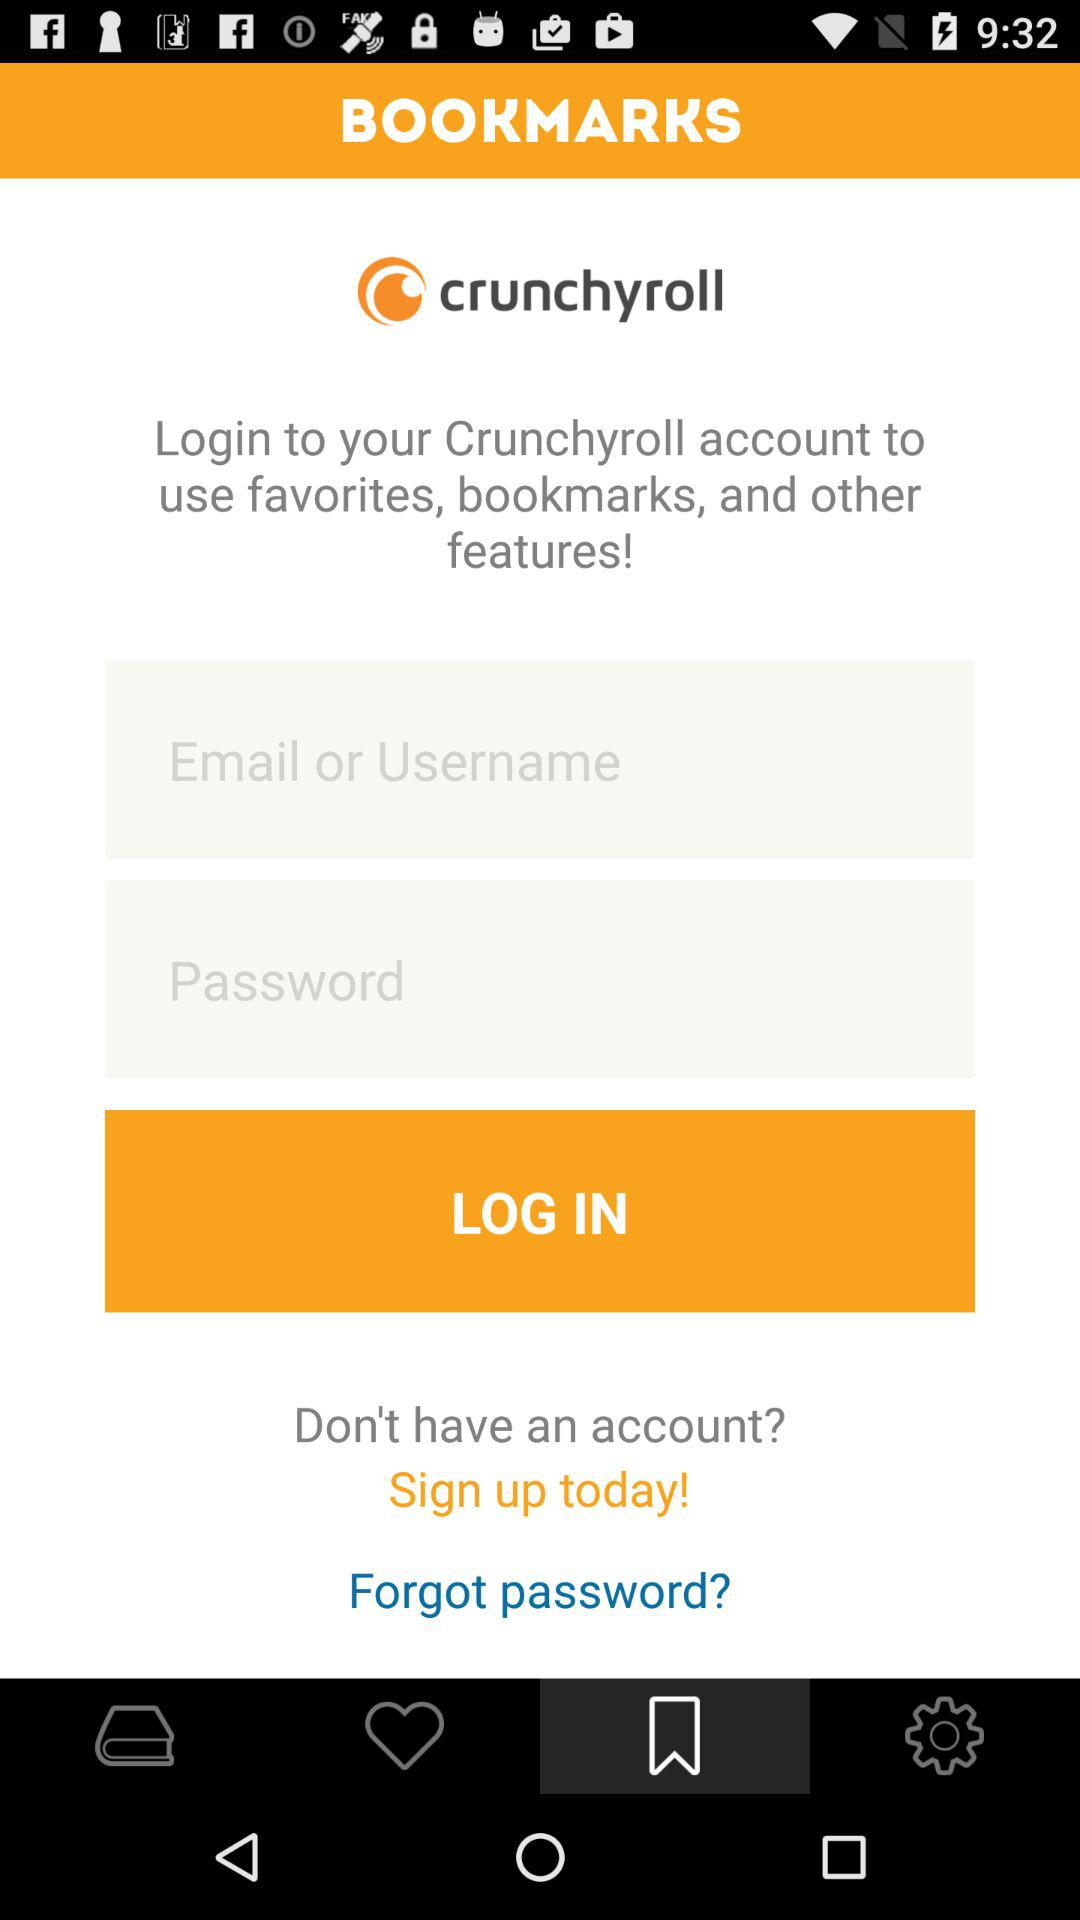What’s the app name? The app name is "crunchyroll". 